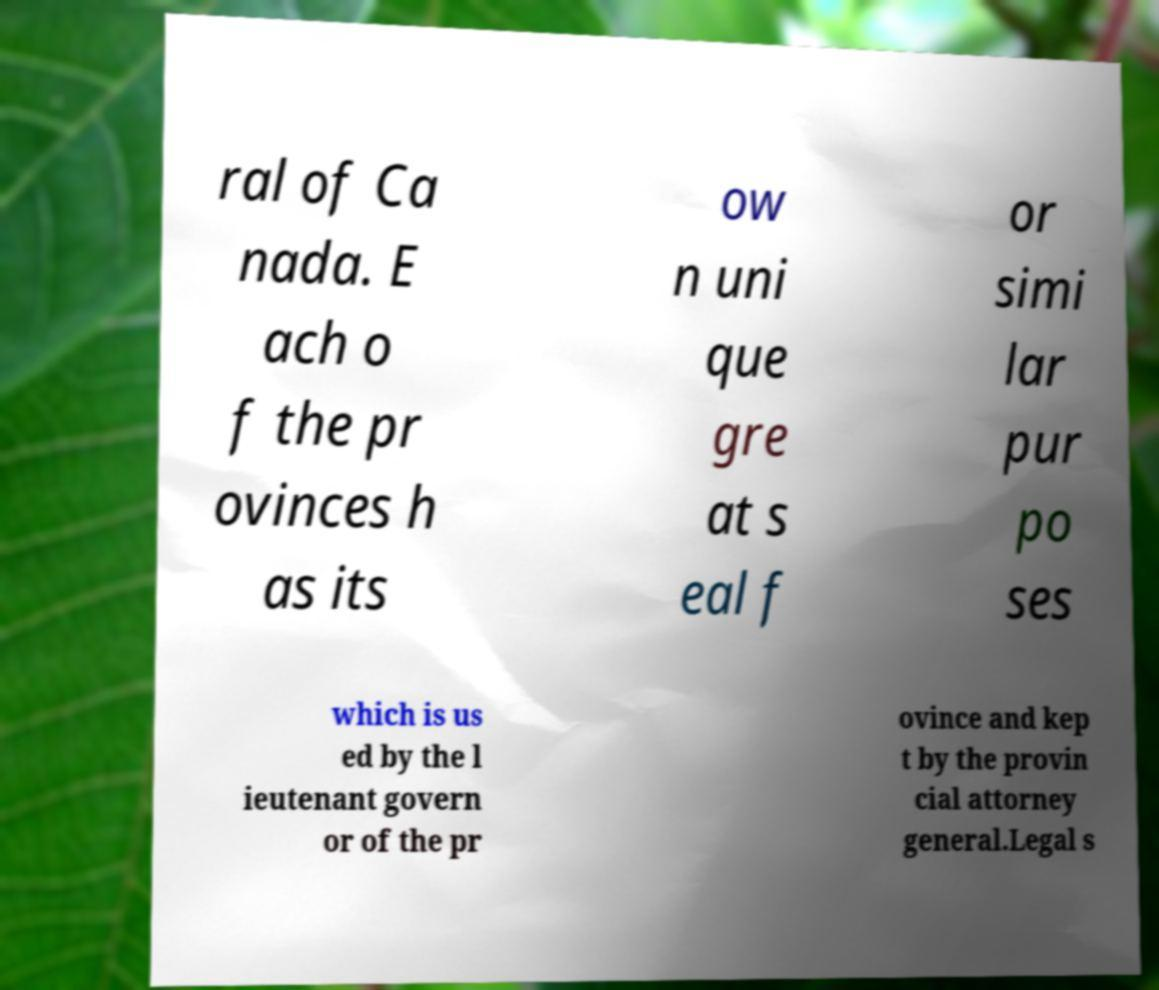Could you assist in decoding the text presented in this image and type it out clearly? ral of Ca nada. E ach o f the pr ovinces h as its ow n uni que gre at s eal f or simi lar pur po ses which is us ed by the l ieutenant govern or of the pr ovince and kep t by the provin cial attorney general.Legal s 